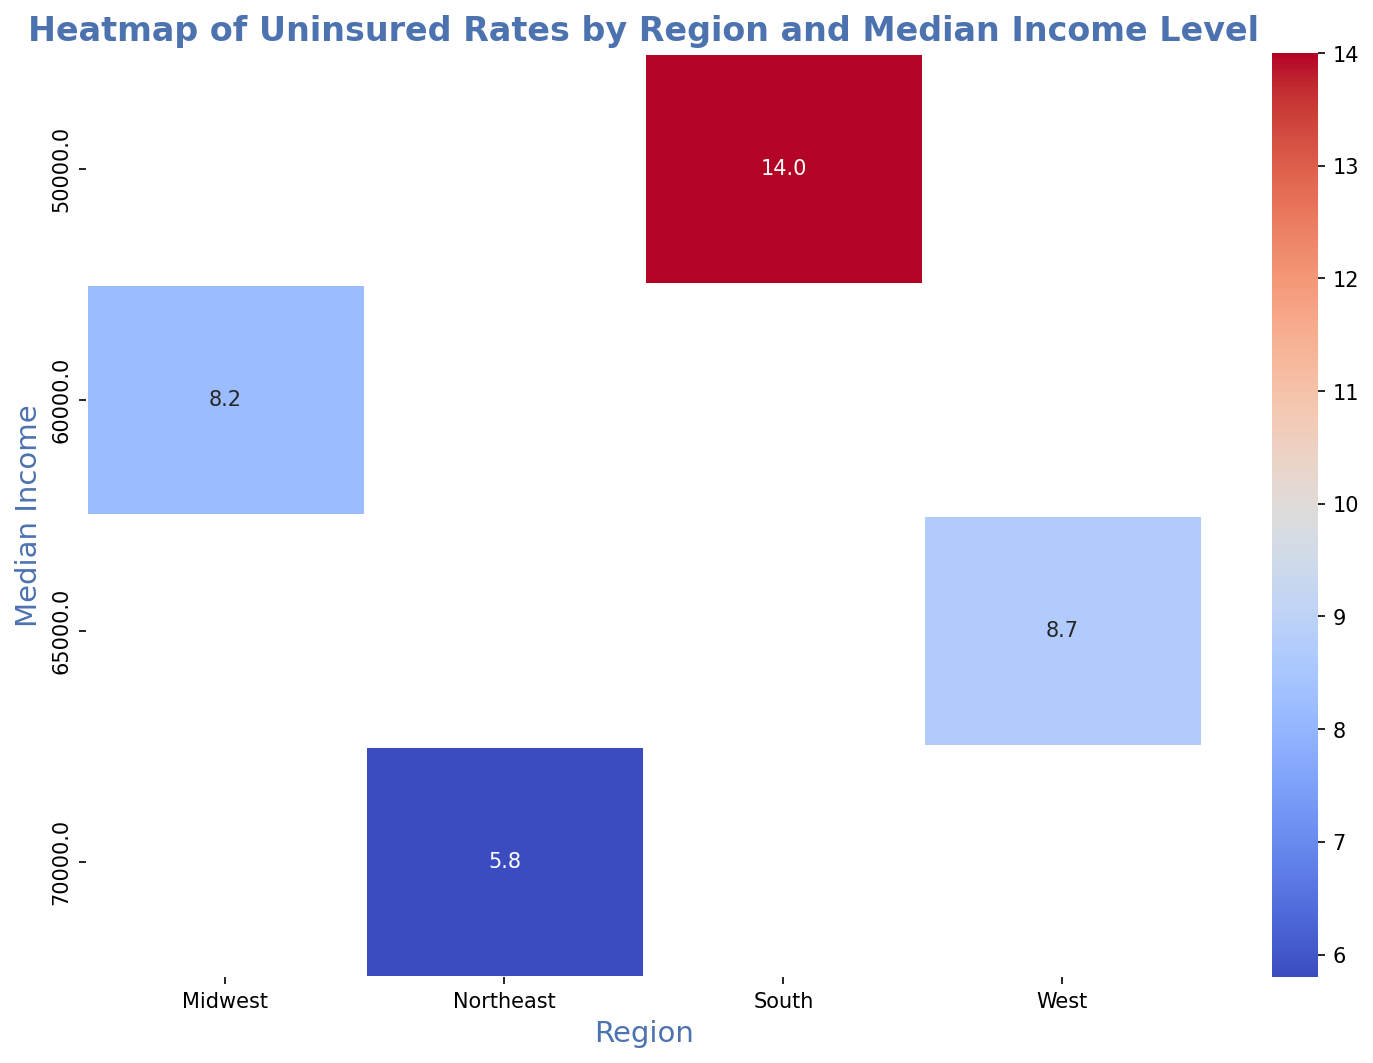Which region has the lowest uninsured rate? By looking at the heatmap, the lowest uninsured rate is represented by the square with the lightest color. For the Northeast region, the lowest rate is 4.9%.
Answer: Northeast Which region has the highest uninsured rate? The heatmap shows the darkest colored square representing the highest uninsured rate. In the South region, this is 15.6%.
Answer: South What is the median income level for the Midwest region? From the heatmap, we can see that the median income level is mentioned on the y-axis for each region. For the Midwest, it is $60,000.
Answer: $60,000 Is the uninsured rate higher in the West or the Midwest for their respective median incomes? Comparing the corresponding squares for the West ($65,000 - 8.7%, $62,000 - 9.3%, $66,000 - 7.2%) and the Midwest ($60,000 - 8.2%, $58,000 - 9.1%, $62,000 - 7.5%), the West has lower rates generally.
Answer: Midwest What is the range of uninsured rates in the South region? The uninsured rates for South are 14.0%, 15.6%, and 12.8%. The range is calculated as the difference between the highest and lowest rates: 15.6% - 12.8% = 2.8%.
Answer: 2.8% Which income level has the lowest uninsured rate in the Northeast region? For the Northeast region, we look at the intersections of $65,000 (6.4%), $70,000 (5.8%), and $72,000 (4.9%). The lowest uninsured rate is at $72,000.
Answer: $72,000 How does the uninsured rate change as median income increases in the Northeast region? In the Northeast region, as median income increases from $65,000 to $72,000, the uninsured rate decreases from 6.4% to 4.9%. This suggests an inverse relationship between income and uninsured rates.
Answer: Decreases Among all regions, which median income level has an uninsured rate closest to 9%? By observing the heatmap, $58,000 in the Midwest (9.1%) and $62,000 in the West (9.3%) are closest to 9%.
Answer: $62,000 in the West and $58,000 in the Midwest Which visual attribute of the heatmap indicates the uninsured rate? The color intensity of the squares indicates the uninsured rate, with lighter colors representing lower rates and darker colors representing higher rates.
Answer: Color intensity Does a higher median income always correlate with a lower uninsured rate across different regions? Observing the heatmap, this is generally true, but not always. For example, $60,000 in the Midwest has an 8.2% uninsured rate, while $65,000 in the West has an 8.7% uninsured rate. Therefore, while a trend does exist, there are exceptions.
Answer: No 